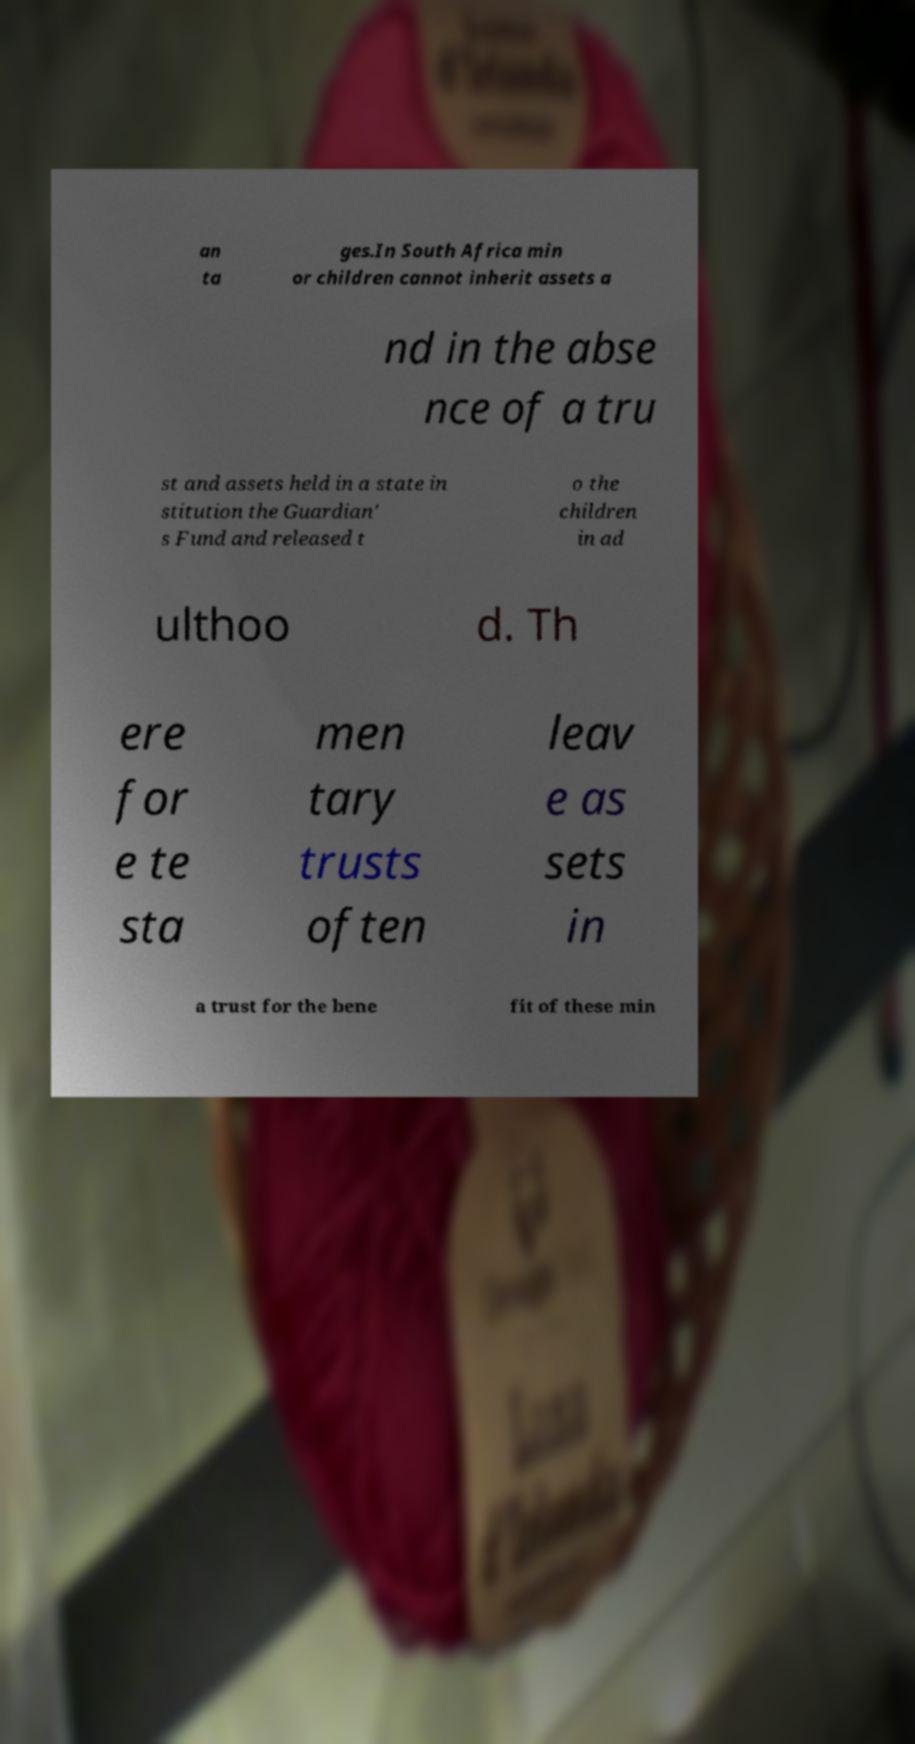What messages or text are displayed in this image? I need them in a readable, typed format. an ta ges.In South Africa min or children cannot inherit assets a nd in the abse nce of a tru st and assets held in a state in stitution the Guardian' s Fund and released t o the children in ad ulthoo d. Th ere for e te sta men tary trusts often leav e as sets in a trust for the bene fit of these min 